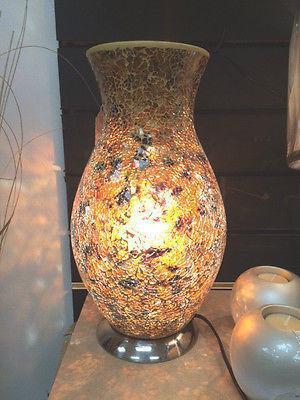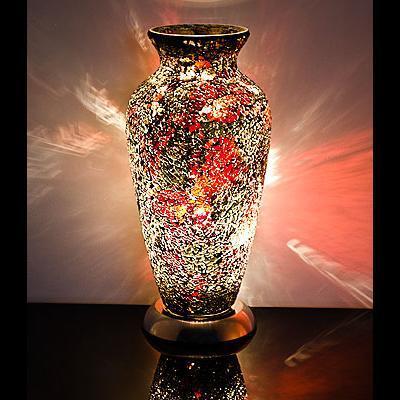The first image is the image on the left, the second image is the image on the right. Given the left and right images, does the statement "A glowing vase is sitting on a wood-like stand with at least two short legs." hold true? Answer yes or no. No. The first image is the image on the left, the second image is the image on the right. For the images displayed, is the sentence "One vase has a narrow neck, a footed base, and a circular design on the front, and it is seen head-on." factually correct? Answer yes or no. No. 